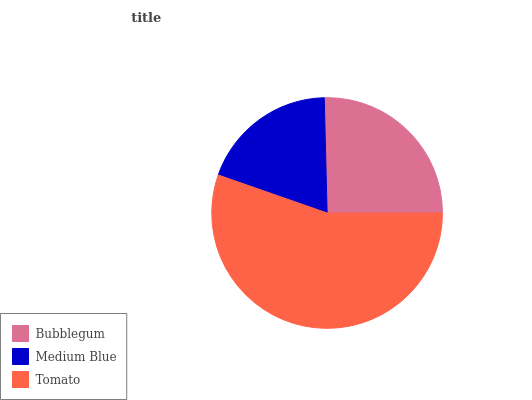Is Medium Blue the minimum?
Answer yes or no. Yes. Is Tomato the maximum?
Answer yes or no. Yes. Is Tomato the minimum?
Answer yes or no. No. Is Medium Blue the maximum?
Answer yes or no. No. Is Tomato greater than Medium Blue?
Answer yes or no. Yes. Is Medium Blue less than Tomato?
Answer yes or no. Yes. Is Medium Blue greater than Tomato?
Answer yes or no. No. Is Tomato less than Medium Blue?
Answer yes or no. No. Is Bubblegum the high median?
Answer yes or no. Yes. Is Bubblegum the low median?
Answer yes or no. Yes. Is Medium Blue the high median?
Answer yes or no. No. Is Medium Blue the low median?
Answer yes or no. No. 